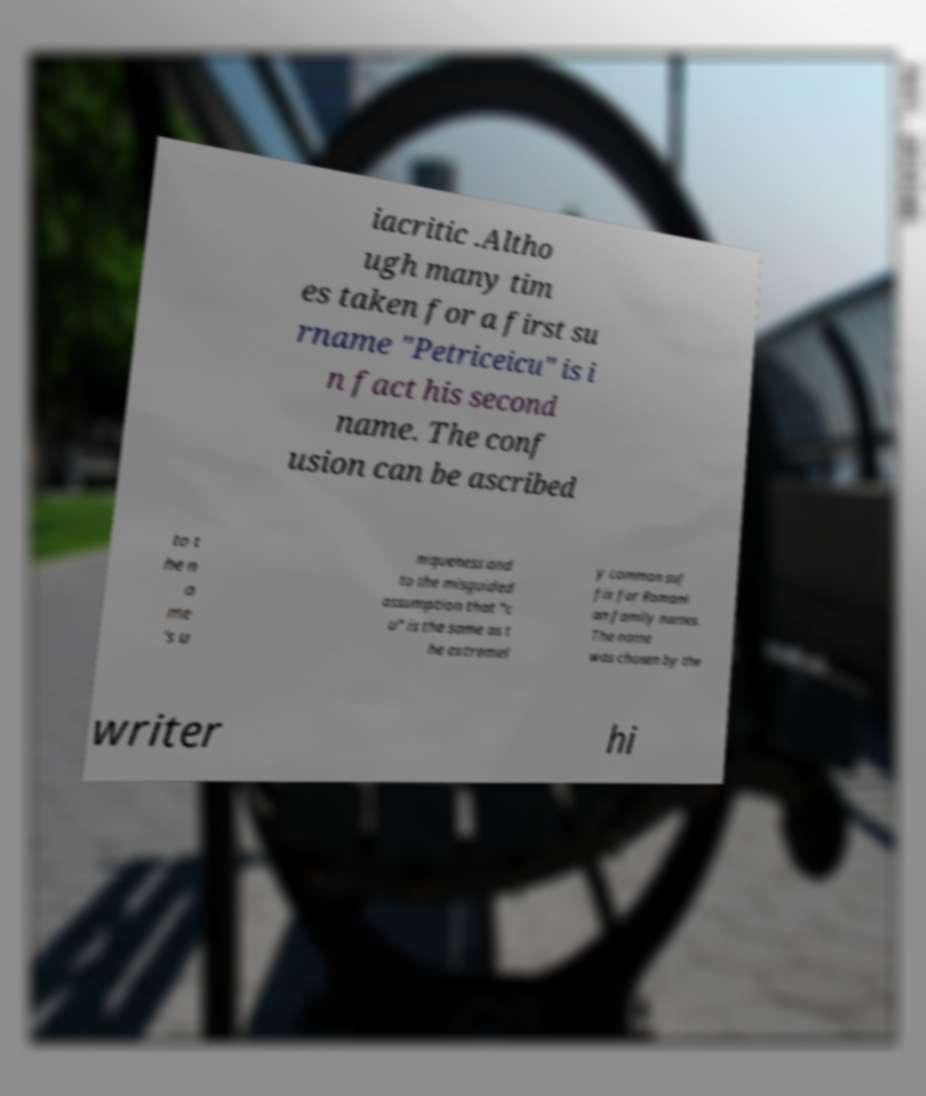There's text embedded in this image that I need extracted. Can you transcribe it verbatim? iacritic .Altho ugh many tim es taken for a first su rname "Petriceicu" is i n fact his second name. The conf usion can be ascribed to t he n a me 's u niqueness and to the misguided assumption that "c u" is the same as t he extremel y common suf fix for Romani an family names. The name was chosen by the writer hi 